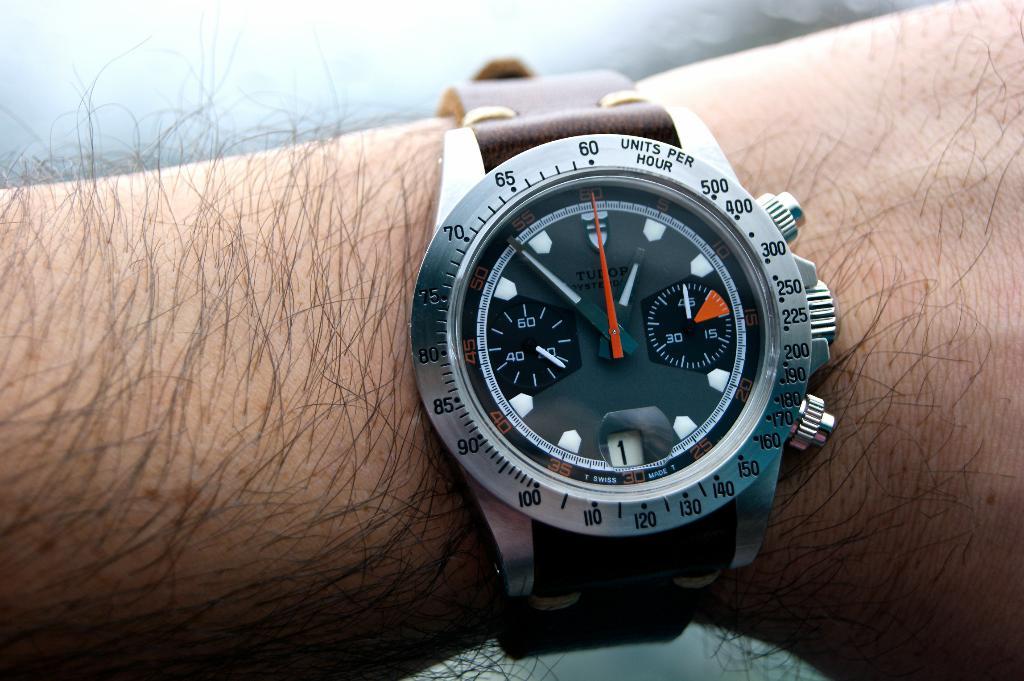What is measured on this watch apart from the time, of course?
Provide a short and direct response. Units per hour. What is the brand of this watch?
Provide a succinct answer. Tudor. 